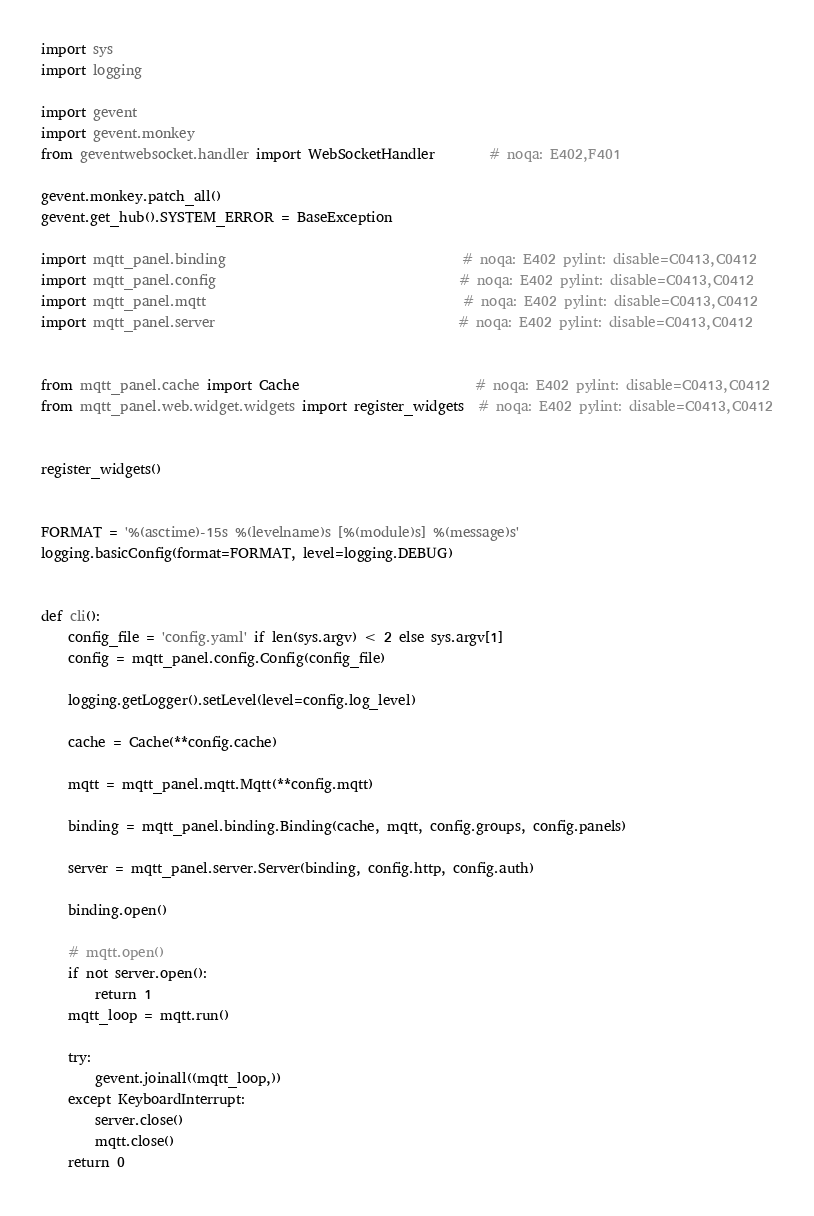<code> <loc_0><loc_0><loc_500><loc_500><_Python_>import sys
import logging

import gevent
import gevent.monkey
from geventwebsocket.handler import WebSocketHandler        # noqa: E402,F401

gevent.monkey.patch_all()
gevent.get_hub().SYSTEM_ERROR = BaseException

import mqtt_panel.binding                                   # noqa: E402 pylint: disable=C0413,C0412
import mqtt_panel.config                                    # noqa: E402 pylint: disable=C0413,C0412
import mqtt_panel.mqtt                                      # noqa: E402 pylint: disable=C0413,C0412
import mqtt_panel.server                                    # noqa: E402 pylint: disable=C0413,C0412


from mqtt_panel.cache import Cache                          # noqa: E402 pylint: disable=C0413,C0412
from mqtt_panel.web.widget.widgets import register_widgets  # noqa: E402 pylint: disable=C0413,C0412


register_widgets()


FORMAT = '%(asctime)-15s %(levelname)s [%(module)s] %(message)s'
logging.basicConfig(format=FORMAT, level=logging.DEBUG)


def cli():
    config_file = 'config.yaml' if len(sys.argv) < 2 else sys.argv[1]
    config = mqtt_panel.config.Config(config_file)

    logging.getLogger().setLevel(level=config.log_level)

    cache = Cache(**config.cache)

    mqtt = mqtt_panel.mqtt.Mqtt(**config.mqtt)

    binding = mqtt_panel.binding.Binding(cache, mqtt, config.groups, config.panels)

    server = mqtt_panel.server.Server(binding, config.http, config.auth)

    binding.open()

    # mqtt.open()
    if not server.open():
        return 1
    mqtt_loop = mqtt.run()

    try:
        gevent.joinall((mqtt_loop,))
    except KeyboardInterrupt:
        server.close()
        mqtt.close()
    return 0
</code> 